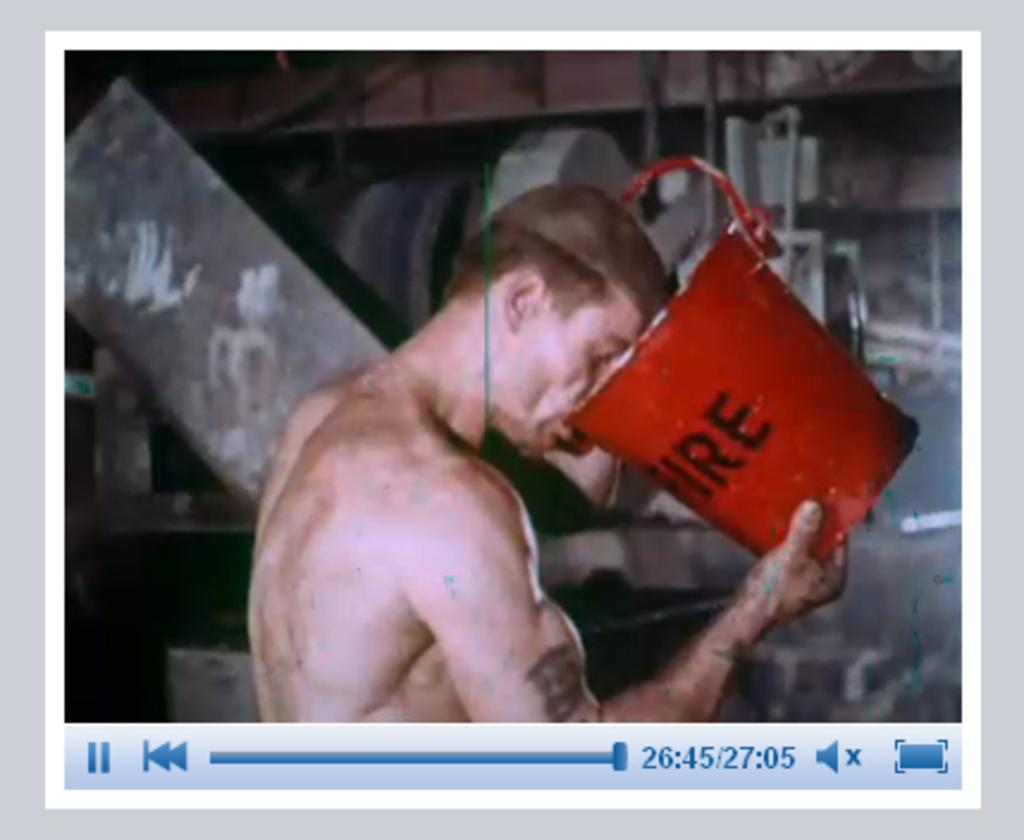What type of image is being described? The image is a screenshot of a video clip. What can be seen in the video clip? The video clip shows a person. What is the person doing in the video clip? The person is drinking water from a bucket. Can you see a snake interacting with the person in the video clip? No, there is no snake present in the video clip. What type of toad is sitting next to the person in the video clip? There is no toad present in the video clip; the person is drinking water from a bucket. 